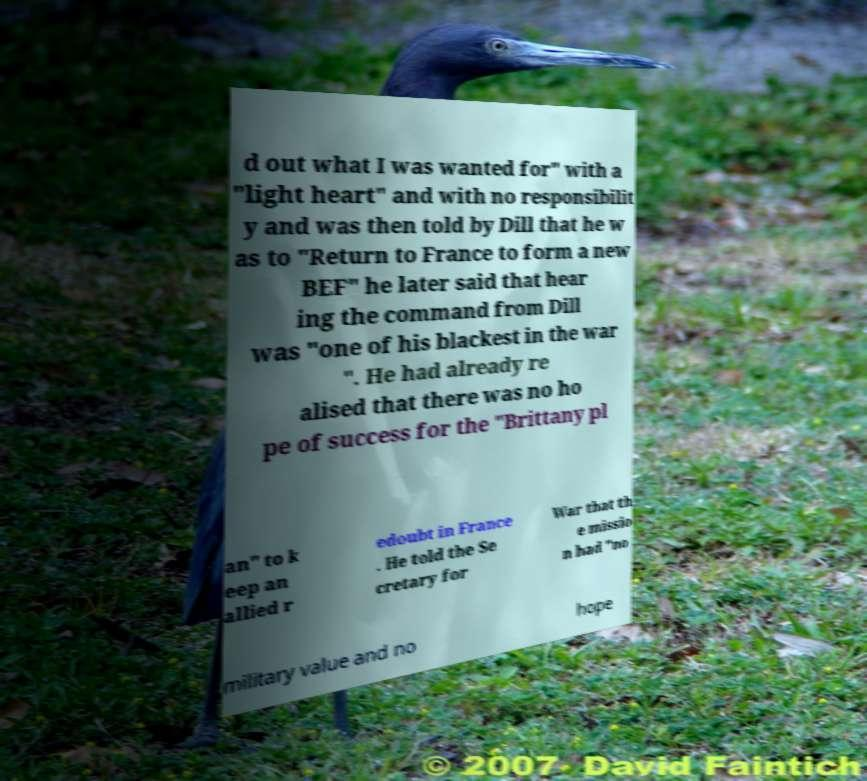Please identify and transcribe the text found in this image. d out what I was wanted for" with a "light heart" and with no responsibilit y and was then told by Dill that he w as to "Return to France to form a new BEF" he later said that hear ing the command from Dill was "one of his blackest in the war ". He had already re alised that there was no ho pe of success for the "Brittany pl an" to k eep an allied r edoubt in France . He told the Se cretary for War that th e missio n had "no military value and no hope 